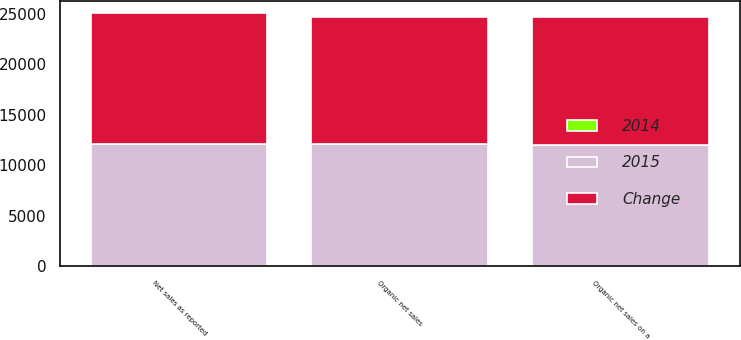Convert chart. <chart><loc_0><loc_0><loc_500><loc_500><stacked_bar_chart><ecel><fcel>Net sales as reported<fcel>Organic net sales<fcel>Organic net sales on a<nl><fcel>Change<fcel>12988.7<fcel>12638<fcel>12638<nl><fcel>2015<fcel>12074.5<fcel>12074.5<fcel>12003<nl><fcel>2014<fcel>7.6<fcel>4.7<fcel>5.3<nl></chart> 